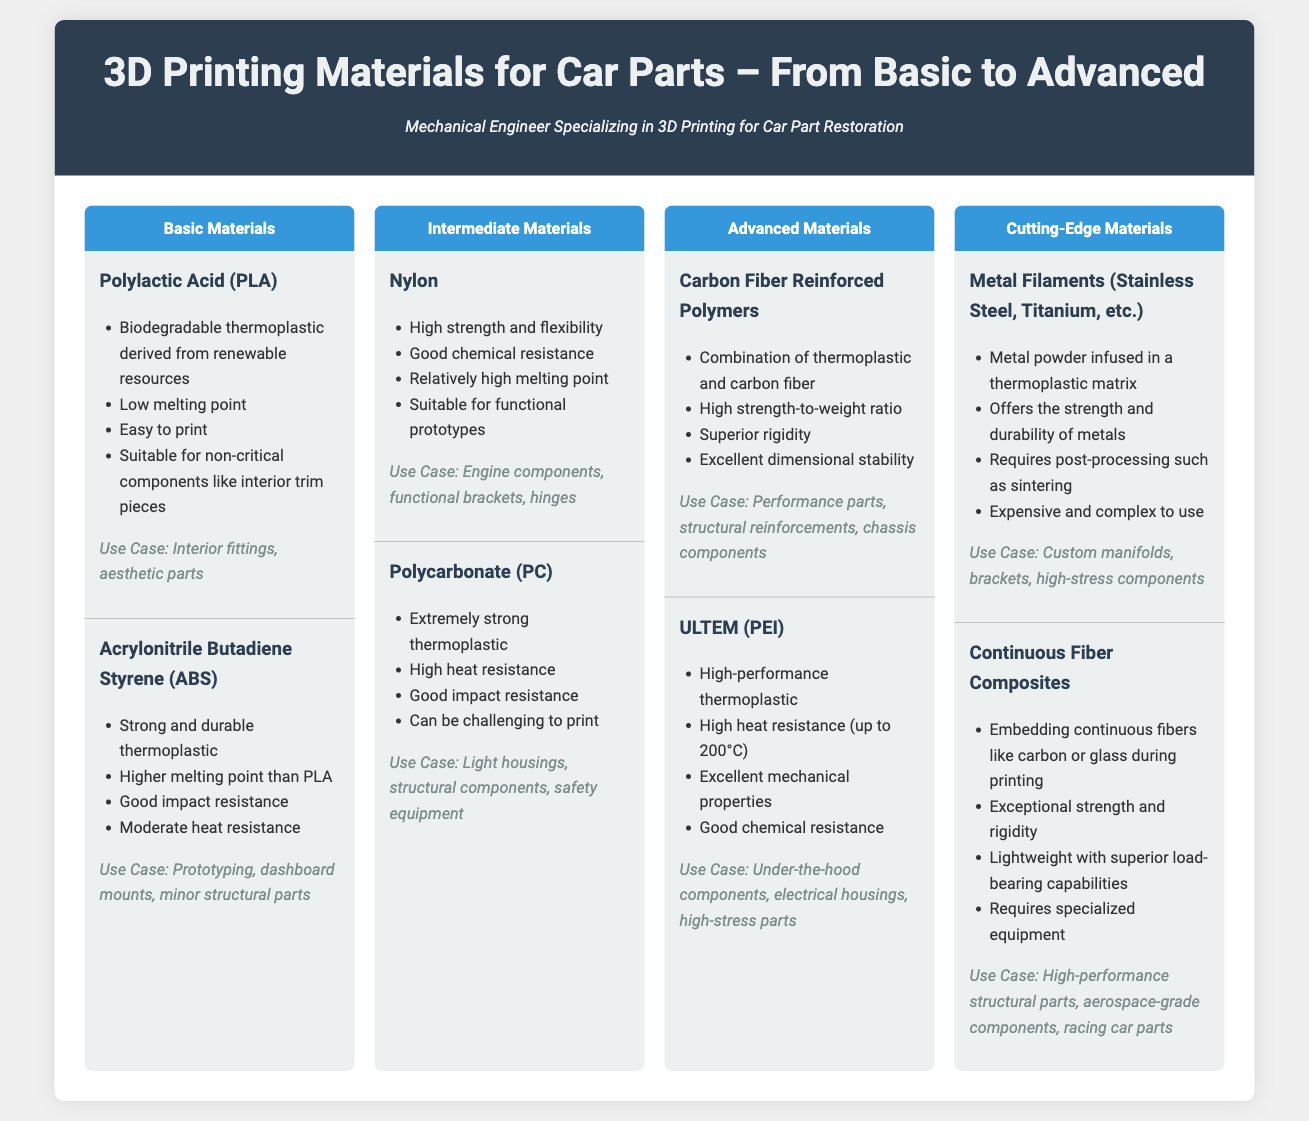What are the basic materials listed? The document specifies that the basic materials listed are Polylactic Acid (PLA) and Acrylonitrile Butadiene Styrene (ABS).
Answer: Polylactic Acid (PLA), Acrylonitrile Butadiene Styrene (ABS) What is the use case for Nylon? The use case for Nylon, as stated in the document, is engine components, functional brackets, and hinges.
Answer: Engine components, functional brackets, hinges What is the melting point capability of ULTEM? The document mentions that ULTEM has high heat resistance up to 200°C.
Answer: Up to 200°C Which advanced material has a high strength-to-weight ratio? Carbon Fiber Reinforced Polymers are noted for their high strength-to-weight ratio in the document.
Answer: Carbon Fiber Reinforced Polymers What defines Cutting-Edge Materials in the document? Cutting-Edge Materials are defined by their incorporation of metal filaments and continuous fiber composites.
Answer: Metal Filaments, Continuous Fiber Composites Which intermediate material is described as extremely strong and has high heat resistance? The document identifies Polycarbonate (PC) as extremely strong with high heat resistance.
Answer: Polycarbonate (PC) How many levels of materials are discussed in the document? The document discusses four levels of materials: Basic, Intermediate, Advanced, and Cutting-Edge.
Answer: Four levels What type of materials is ULTEM classified as? ULTEM is classified as a high-performance thermoplastic in the document.
Answer: High-performance thermoplastic What are the components listed under Cutting-Edge Materials? The components listed under Cutting-Edge Materials include Metal Filaments and Continuous Fiber Composites.
Answer: Metal Filaments, Continuous Fiber Composites 